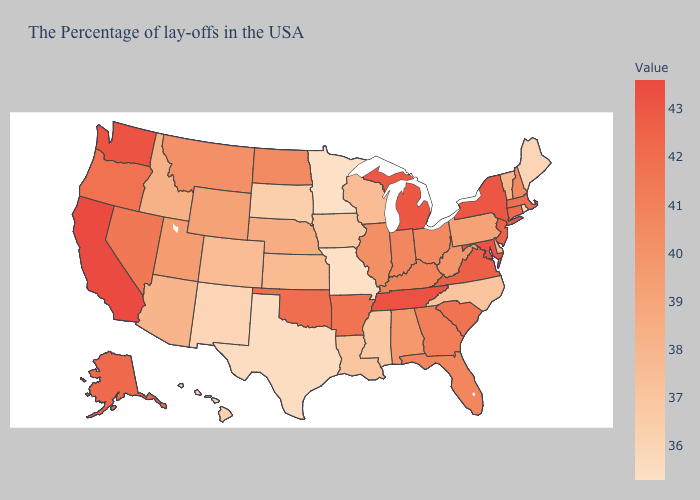Does California have the highest value in the USA?
Write a very short answer. Yes. Does Maryland have the highest value in the South?
Short answer required. Yes. Does Tennessee have the lowest value in the South?
Be succinct. No. Does Nevada have the lowest value in the West?
Concise answer only. No. Which states have the lowest value in the Northeast?
Write a very short answer. Rhode Island. Which states have the highest value in the USA?
Short answer required. California. 